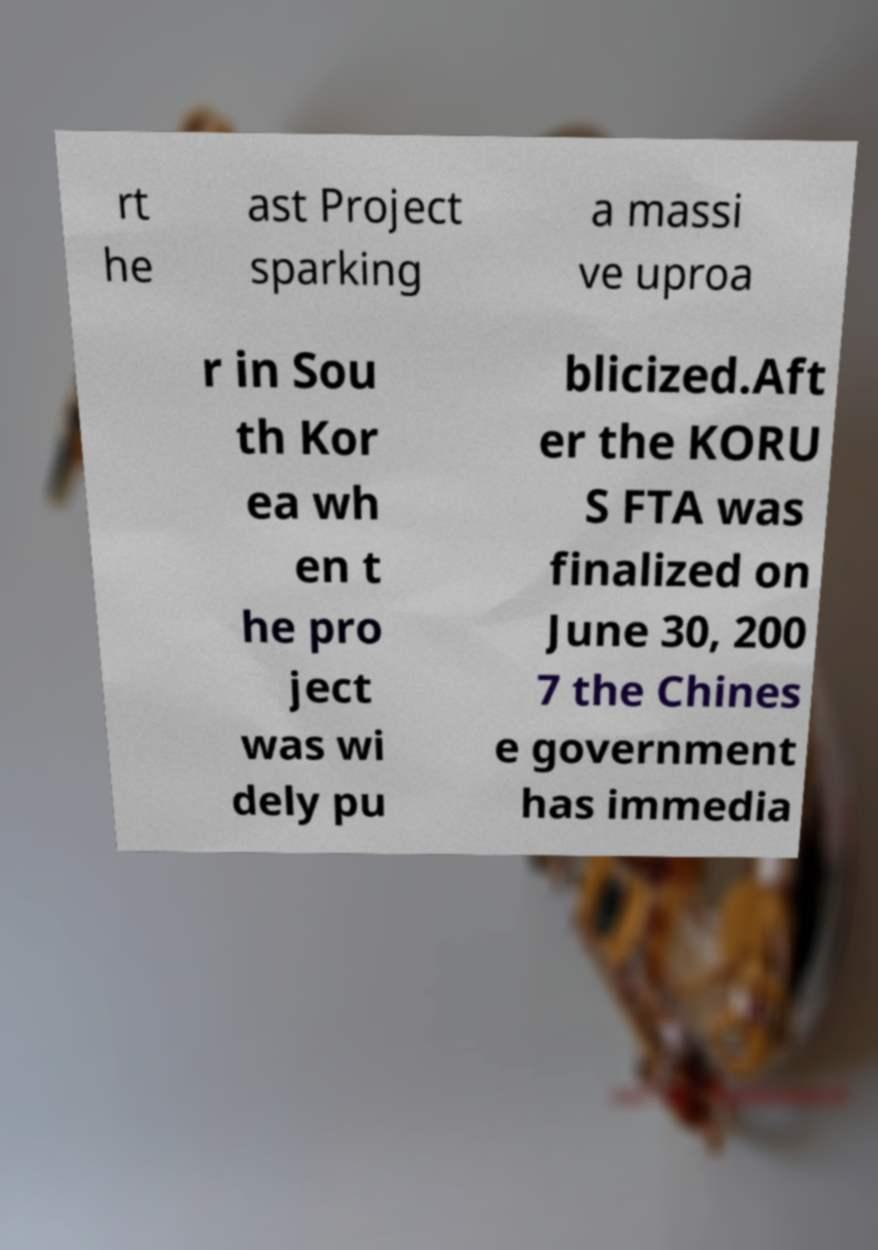Please identify and transcribe the text found in this image. rt he ast Project sparking a massi ve uproa r in Sou th Kor ea wh en t he pro ject was wi dely pu blicized.Aft er the KORU S FTA was finalized on June 30, 200 7 the Chines e government has immedia 